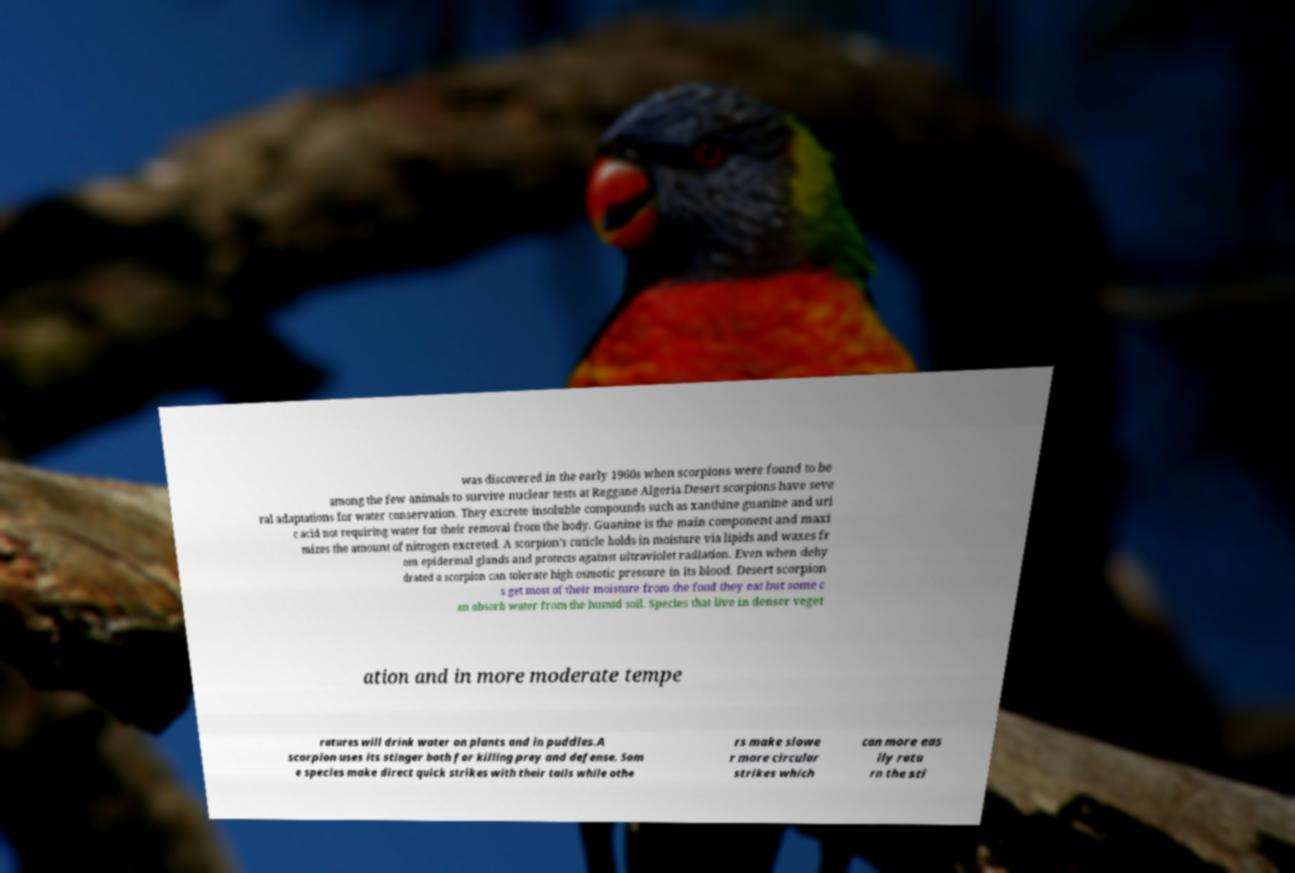There's text embedded in this image that I need extracted. Can you transcribe it verbatim? was discovered in the early 1960s when scorpions were found to be among the few animals to survive nuclear tests at Reggane Algeria.Desert scorpions have seve ral adaptations for water conservation. They excrete insoluble compounds such as xanthine guanine and uri c acid not requiring water for their removal from the body. Guanine is the main component and maxi mizes the amount of nitrogen excreted. A scorpion's cuticle holds in moisture via lipids and waxes fr om epidermal glands and protects against ultraviolet radiation. Even when dehy drated a scorpion can tolerate high osmotic pressure in its blood. Desert scorpion s get most of their moisture from the food they eat but some c an absorb water from the humid soil. Species that live in denser veget ation and in more moderate tempe ratures will drink water on plants and in puddles.A scorpion uses its stinger both for killing prey and defense. Som e species make direct quick strikes with their tails while othe rs make slowe r more circular strikes which can more eas ily retu rn the sti 